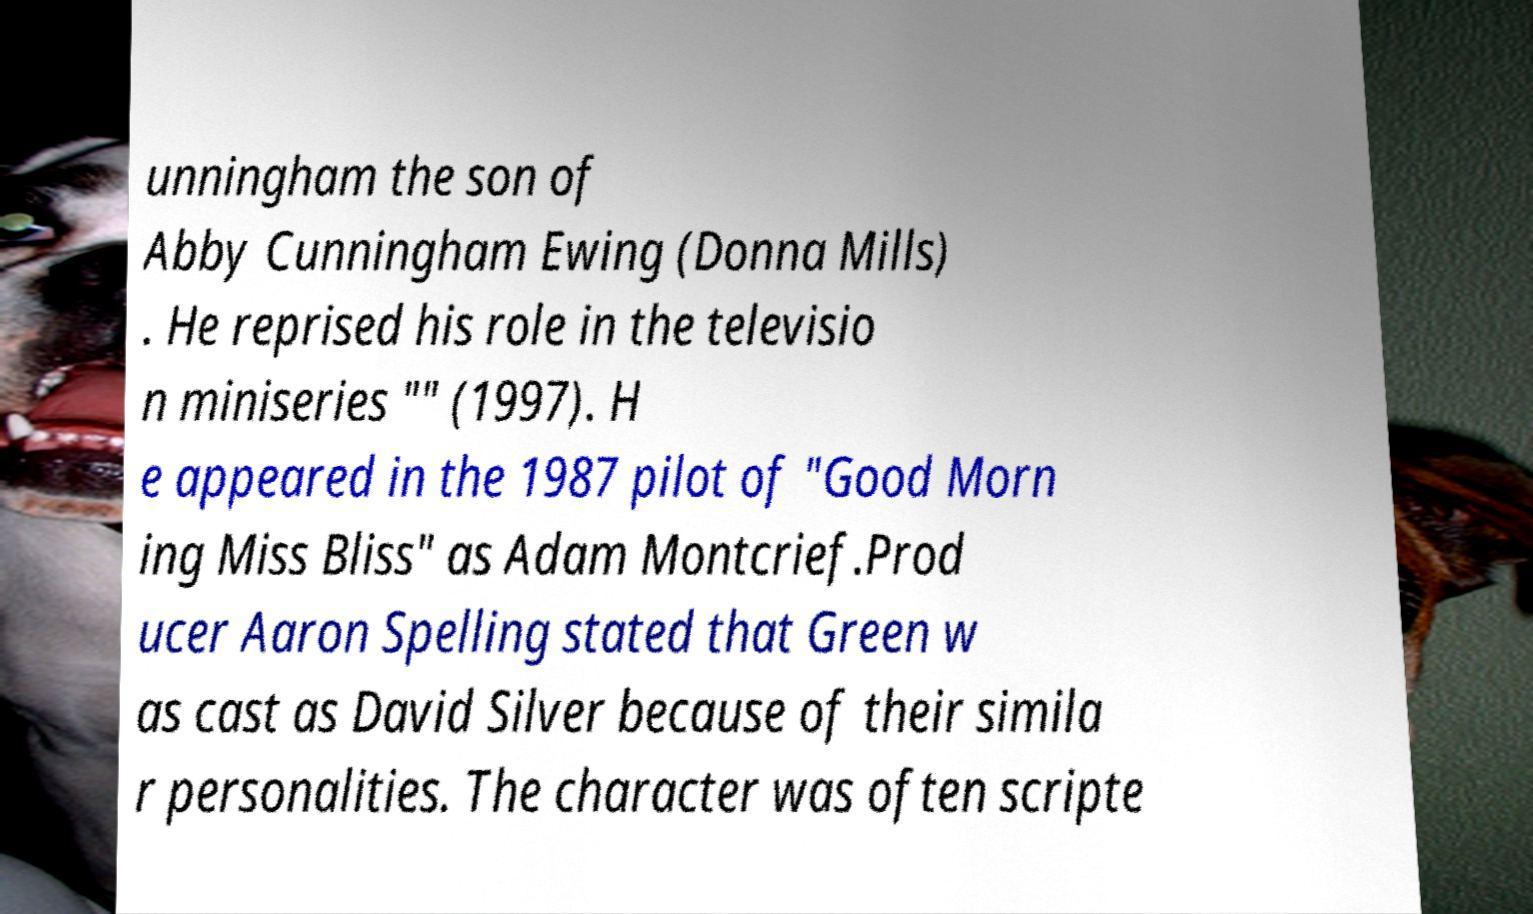Please read and relay the text visible in this image. What does it say? unningham the son of Abby Cunningham Ewing (Donna Mills) . He reprised his role in the televisio n miniseries "" (1997). H e appeared in the 1987 pilot of "Good Morn ing Miss Bliss" as Adam Montcrief.Prod ucer Aaron Spelling stated that Green w as cast as David Silver because of their simila r personalities. The character was often scripte 